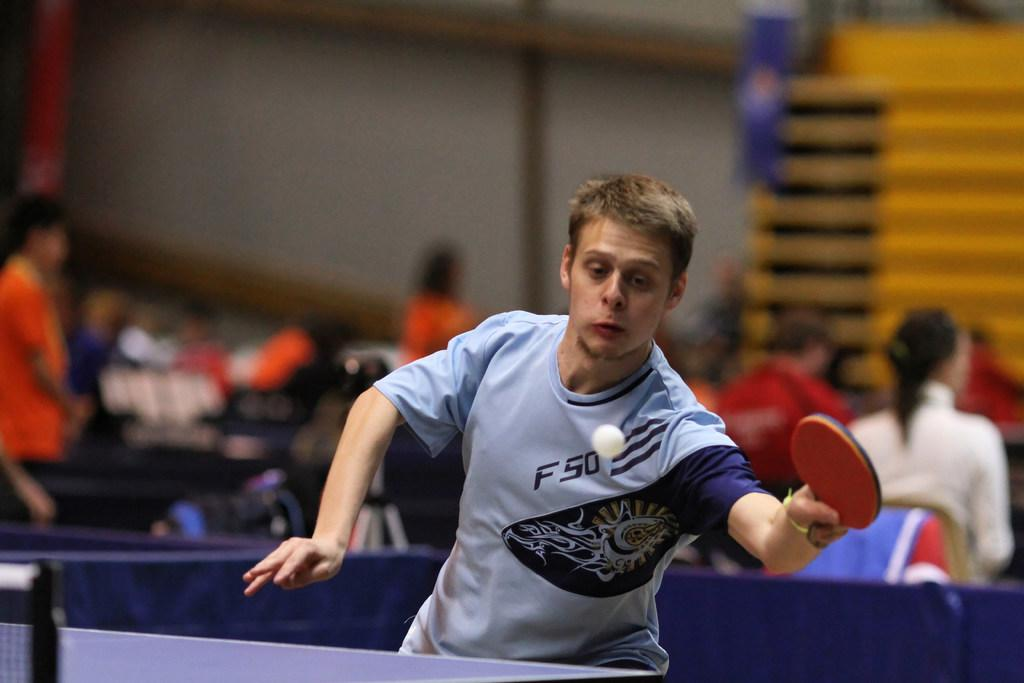<image>
Relay a brief, clear account of the picture shown. a man playing table tennis while wearing an f50 shirt 